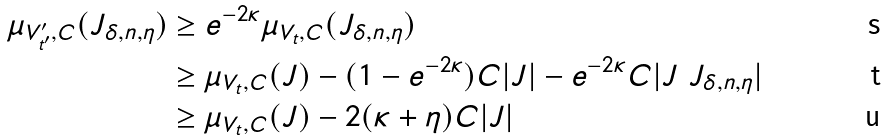<formula> <loc_0><loc_0><loc_500><loc_500>\mu _ { V ^ { \prime } _ { t ^ { \prime } } , C } ( J _ { \delta , n , \eta } ) & \geq e ^ { - 2 \kappa } \mu _ { V _ { t } , C } ( J _ { \delta , n , \eta } ) \\ & \geq \mu _ { V _ { t } , C } ( J ) - ( 1 - e ^ { - 2 \kappa } ) C | J | - e ^ { - 2 \kappa } C | J \ J _ { \delta , n , \eta } | \\ & \geq \mu _ { V _ { t } , C } ( J ) - 2 ( \kappa + \eta ) C | J |</formula> 